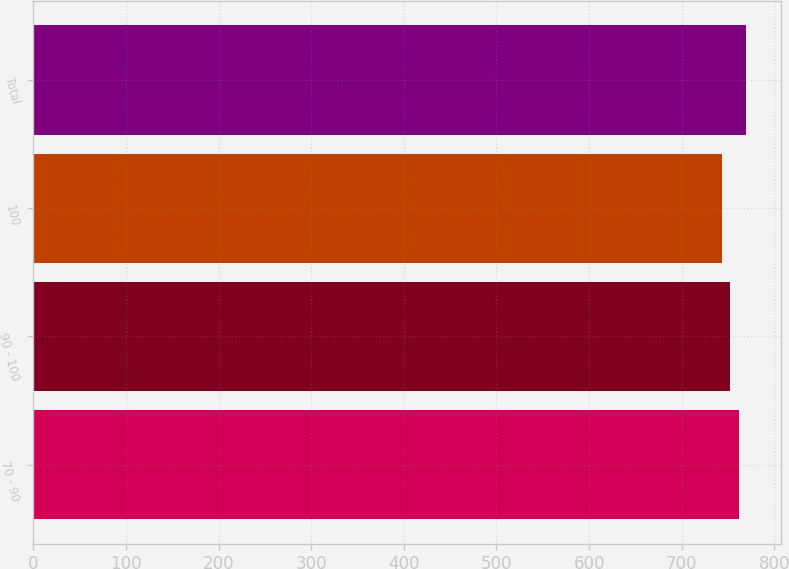<chart> <loc_0><loc_0><loc_500><loc_500><bar_chart><fcel>70 - 90<fcel>90 - 100<fcel>100<fcel>Total<nl><fcel>762<fcel>752<fcel>743<fcel>769<nl></chart> 